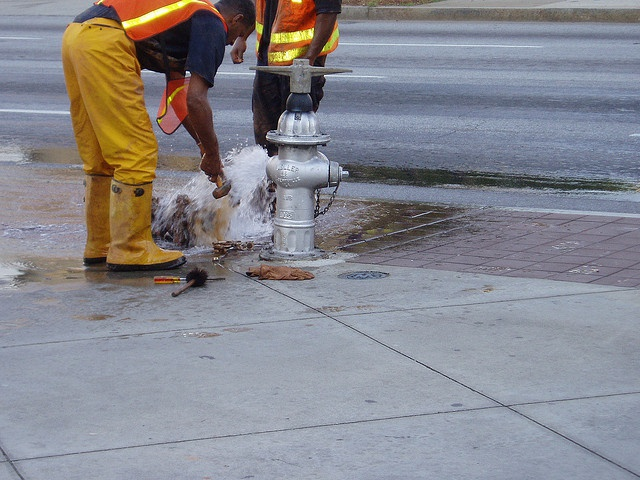Describe the objects in this image and their specific colors. I can see people in darkgray, olive, black, and maroon tones, fire hydrant in darkgray, gray, black, and lightgray tones, and people in darkgray, black, maroon, and brown tones in this image. 